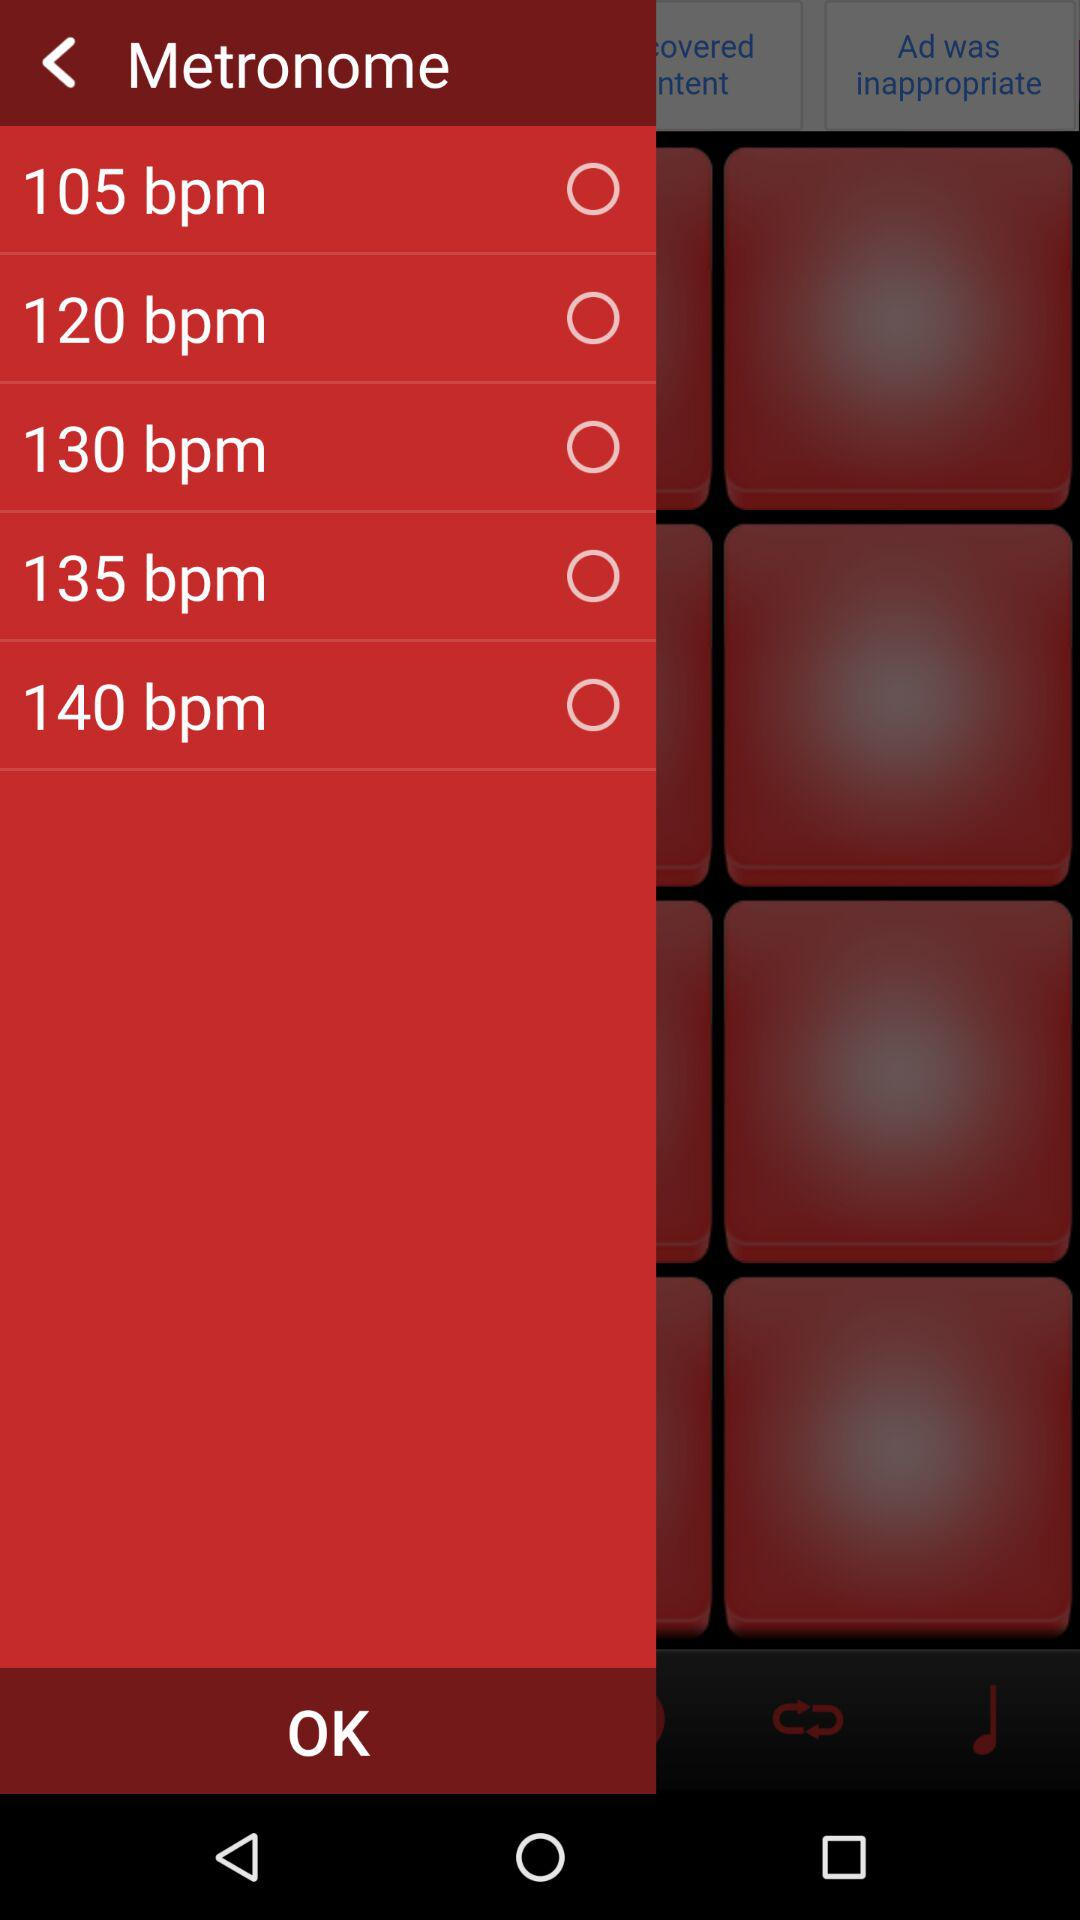How many bpm options are there?
Answer the question using a single word or phrase. 5 